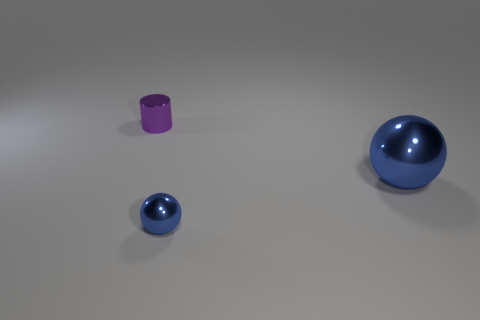Add 1 small red rubber cubes. How many objects exist? 4 Subtract all cylinders. How many objects are left? 2 Subtract 0 red cylinders. How many objects are left? 3 Subtract all purple metallic blocks. Subtract all blue metallic things. How many objects are left? 1 Add 1 small metal things. How many small metal things are left? 3 Add 3 small blue shiny objects. How many small blue shiny objects exist? 4 